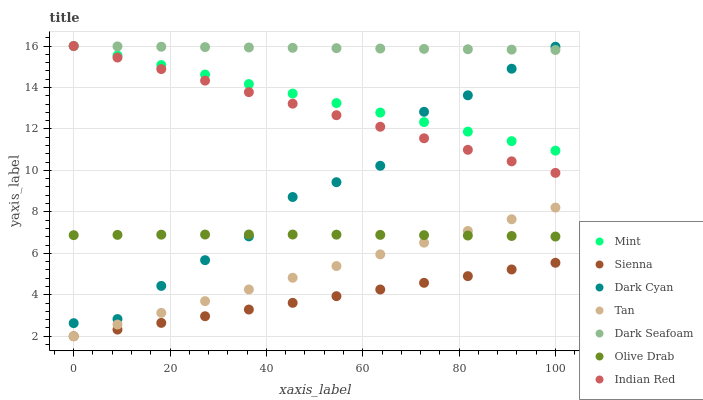Does Sienna have the minimum area under the curve?
Answer yes or no. Yes. Does Dark Seafoam have the maximum area under the curve?
Answer yes or no. Yes. Does Indian Red have the minimum area under the curve?
Answer yes or no. No. Does Indian Red have the maximum area under the curve?
Answer yes or no. No. Is Tan the smoothest?
Answer yes or no. Yes. Is Dark Cyan the roughest?
Answer yes or no. Yes. Is Dark Seafoam the smoothest?
Answer yes or no. No. Is Dark Seafoam the roughest?
Answer yes or no. No. Does Sienna have the lowest value?
Answer yes or no. Yes. Does Indian Red have the lowest value?
Answer yes or no. No. Does Mint have the highest value?
Answer yes or no. Yes. Does Dark Cyan have the highest value?
Answer yes or no. No. Is Sienna less than Dark Seafoam?
Answer yes or no. Yes. Is Indian Red greater than Olive Drab?
Answer yes or no. Yes. Does Dark Seafoam intersect Indian Red?
Answer yes or no. Yes. Is Dark Seafoam less than Indian Red?
Answer yes or no. No. Is Dark Seafoam greater than Indian Red?
Answer yes or no. No. Does Sienna intersect Dark Seafoam?
Answer yes or no. No. 